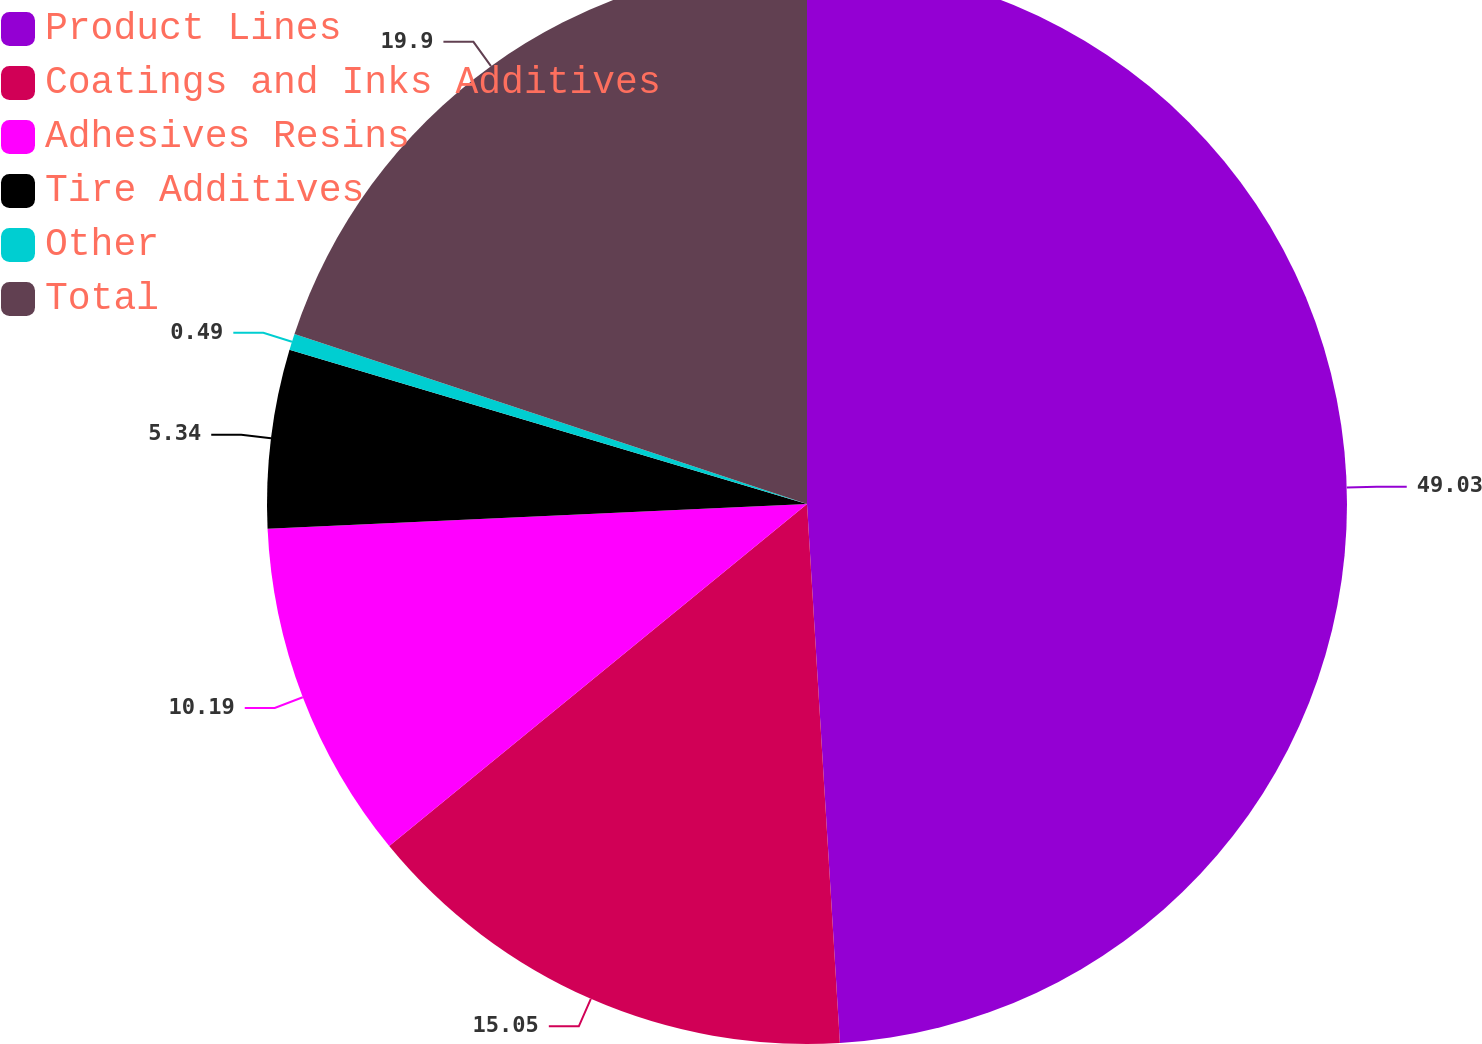Convert chart. <chart><loc_0><loc_0><loc_500><loc_500><pie_chart><fcel>Product Lines<fcel>Coatings and Inks Additives<fcel>Adhesives Resins<fcel>Tire Additives<fcel>Other<fcel>Total<nl><fcel>49.03%<fcel>15.05%<fcel>10.19%<fcel>5.34%<fcel>0.49%<fcel>19.9%<nl></chart> 